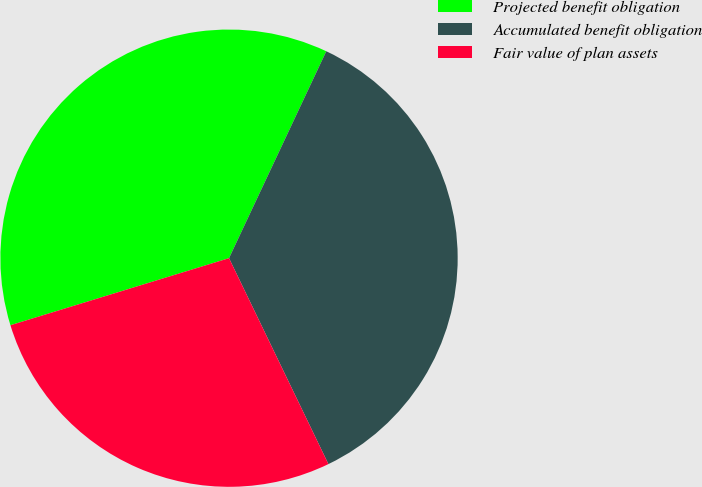Convert chart. <chart><loc_0><loc_0><loc_500><loc_500><pie_chart><fcel>Projected benefit obligation<fcel>Accumulated benefit obligation<fcel>Fair value of plan assets<nl><fcel>36.73%<fcel>35.85%<fcel>27.42%<nl></chart> 